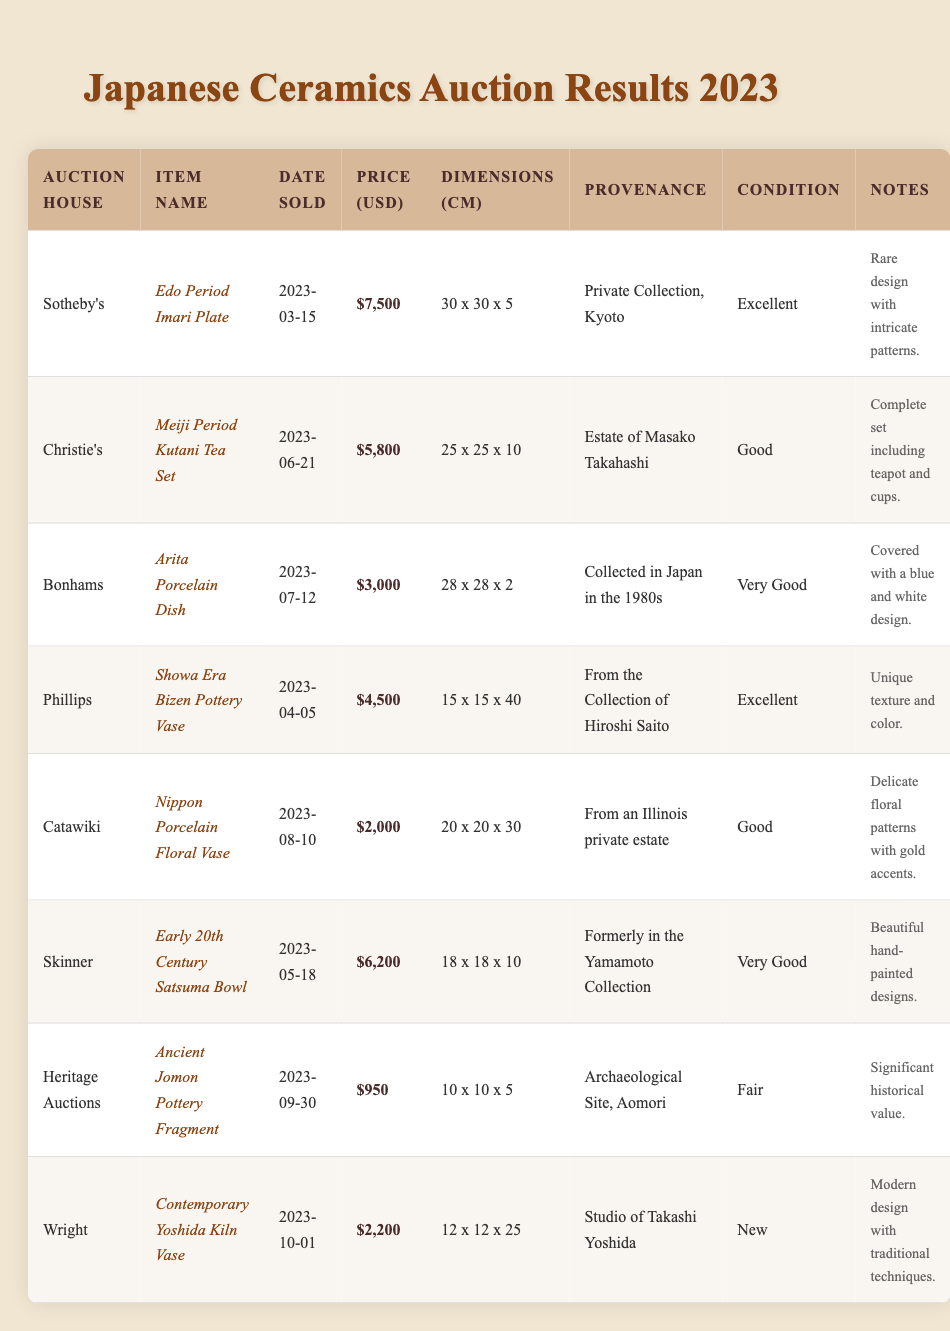What is the highest sale price among the items sold? Looking through the sale prices, the highest amount is $7,500 for the Edo Period Imari Plate sold at Sotheby’s on 2023-03-15.
Answer: $7,500 Which item was sold for the lowest price? The lowest price listed is $950 for the Ancient Jomon Pottery Fragment sold at Heritage Auctions on 2023-09-30.
Answer: $950 How many items were sold in total? There are 8 distinct items listed in the inventory, as confirmed by counting each row in the table.
Answer: 8 Which auction house sold the Meiji Period Kutani Tea Set? The Meiji Period Kutani Tea Set was sold by Christie's on 2023-06-21.
Answer: Christie's What is the total sale value of all items sold? The total sale value is calculated by summing all the individual sale prices: $7,500 + $5,800 + $3,000 + $4,500 + $2,000 + $6,200 + $950 + $2,200 = $32,150.
Answer: $32,150 Which item has "Excellent" as its condition? The items listed with the condition "Excellent" are the Edo Period Imari Plate andthe Showa Era Bizen Pottery Vase.
Answer: Edo Period Imari Plate and Showa Era Bizen Pottery Vase Are there any items with "Good" condition sold at auctions? Yes, the Meiji Period Kutani Tea Set and the Nippon Porcelain Floral Vase are both in "Good" condition.
Answer: Yes What is the average sale price of all items sold? To calculate the average sale price, sum all sales ($32,150) and divide by the number of items (8): $32,150 / 8 = $4,018.75.
Answer: $4,018.75 What percentage of items sold were in "Very Good" condition? Looking at the table, there are 3 items total that are in "Very Good" condition (Arita Porcelain Dish, Early 20th Century Satsuma Bowl), so the percentage is (3/8) * 100 = 37.5%.
Answer: 37.5% Which item was sold on the latest date? The latest date listed is 2023-10-01 for the Contemporary Yoshida Kiln Vase, sold at Wright.
Answer: Contemporary Yoshida Kiln Vase 